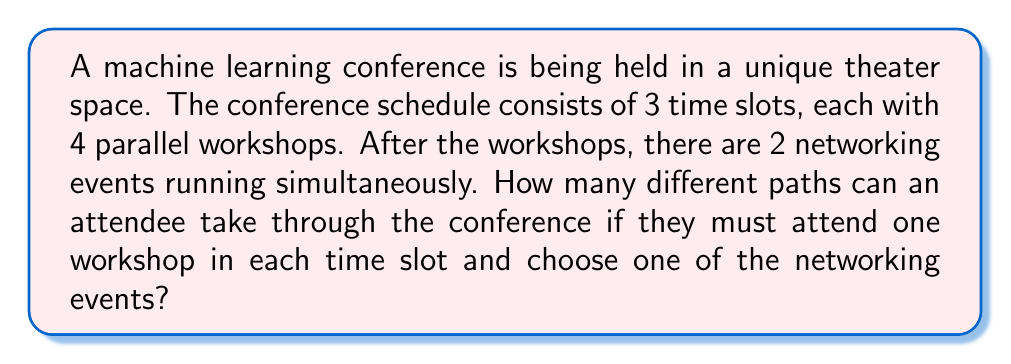Provide a solution to this math problem. Let's break this down step-by-step:

1) For each time slot, the attendee has 4 workshop options to choose from.

2) The attendee must make this choice 3 times (once for each time slot).

3) After the workshops, the attendee must choose 1 of the 2 networking events.

4) This scenario can be modeled using the multiplication principle of counting.

5) For the workshops:
   - First time slot: 4 choices
   - Second time slot: 4 choices
   - Third time slot: 4 choices

6) The number of possible workshop combinations is:

   $4 \times 4 \times 4 = 4^3 = 64$

7) For the networking event, there are 2 choices.

8) To get the total number of unique paths, we multiply the number of workshop combinations by the number of networking event choices:

   $64 \times 2 = 128$

Therefore, there are 128 different paths an attendee can take through the conference.
Answer: 128 